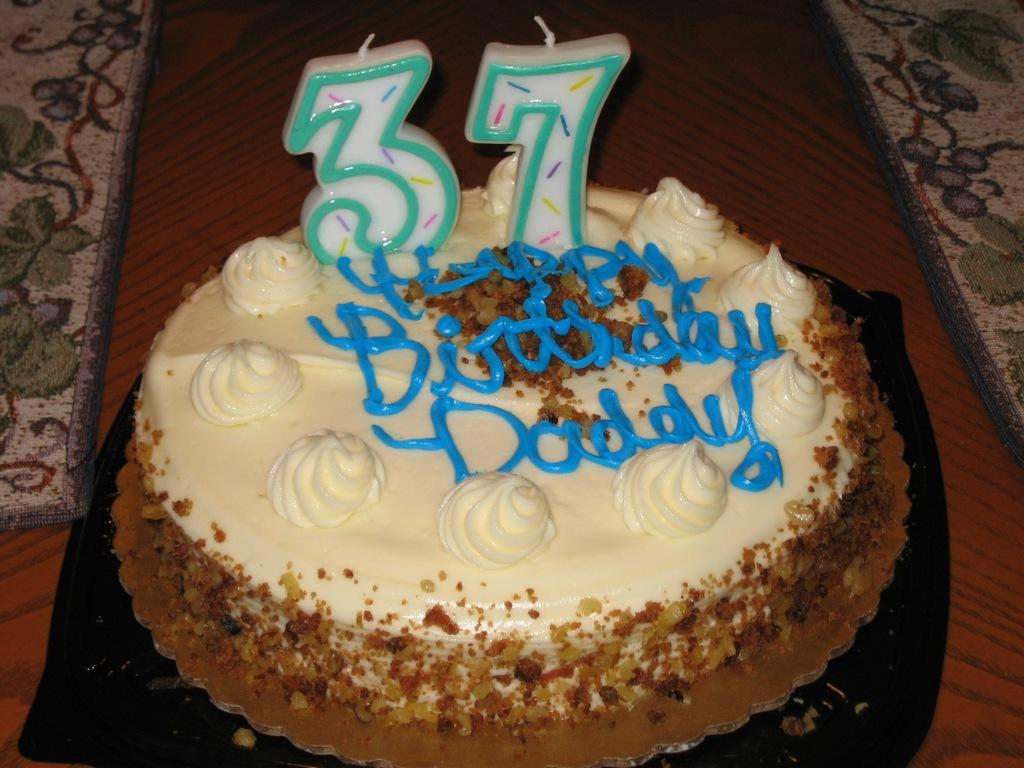What is the main subject of the image? There is a cake in the image. Are there any decorations on the cake? Yes, the cake has candles on it. What else can be seen on the table in the image? There are clothes on the table. What type of railway is visible in the image? There is no railway present in the image; it features a cake with candles and clothes on a table. What kind of work is being done in the image? There is no work being done in the image; it shows a cake with candles and clothes on a table. 